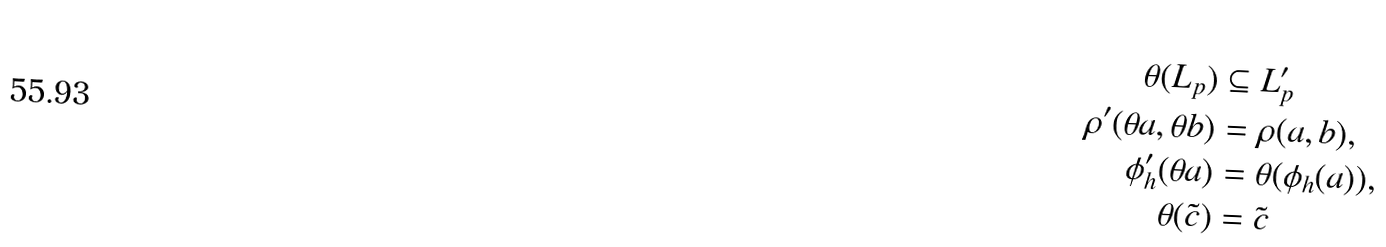<formula> <loc_0><loc_0><loc_500><loc_500>\theta ( L _ { p } ) & \subseteq L _ { p } ^ { \prime } \\ \rho ^ { \prime } ( \theta a , \theta b ) & = \rho ( a , b ) , \\ \phi ^ { \prime } _ { h } ( \theta a ) & = \theta ( \phi _ { h } ( a ) ) , \\ \theta ( \tilde { c } ) & = \tilde { c }</formula> 